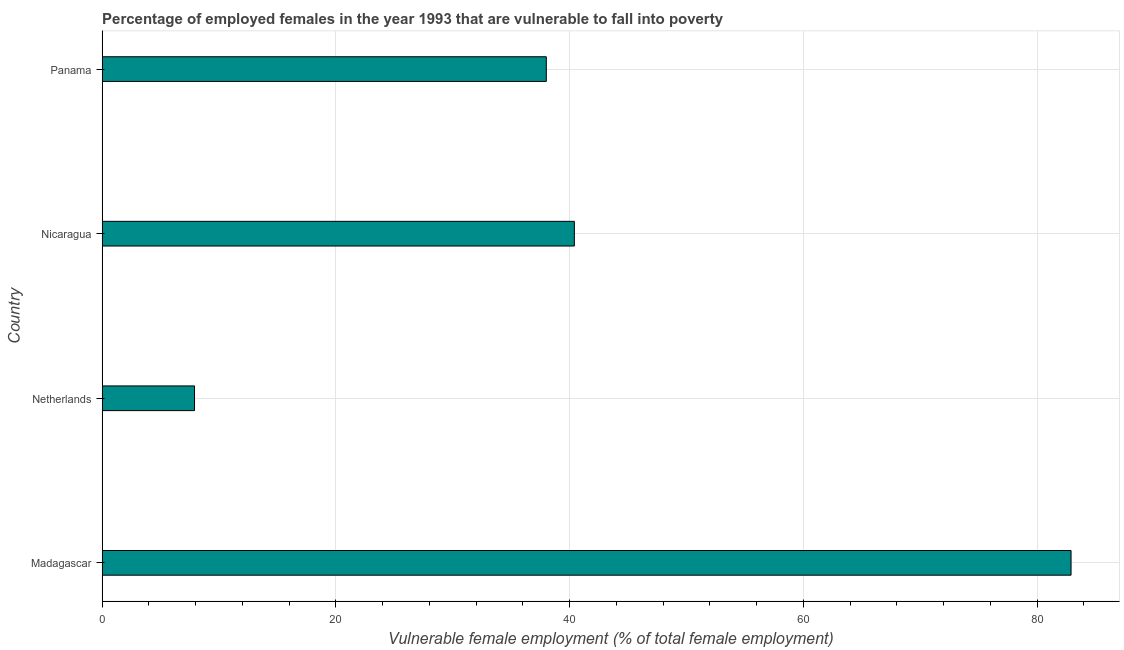Does the graph contain any zero values?
Make the answer very short. No. What is the title of the graph?
Give a very brief answer. Percentage of employed females in the year 1993 that are vulnerable to fall into poverty. What is the label or title of the X-axis?
Offer a terse response. Vulnerable female employment (% of total female employment). What is the label or title of the Y-axis?
Provide a short and direct response. Country. What is the percentage of employed females who are vulnerable to fall into poverty in Madagascar?
Offer a very short reply. 82.9. Across all countries, what is the maximum percentage of employed females who are vulnerable to fall into poverty?
Provide a short and direct response. 82.9. Across all countries, what is the minimum percentage of employed females who are vulnerable to fall into poverty?
Your answer should be compact. 7.9. In which country was the percentage of employed females who are vulnerable to fall into poverty maximum?
Make the answer very short. Madagascar. What is the sum of the percentage of employed females who are vulnerable to fall into poverty?
Your response must be concise. 169.2. What is the difference between the percentage of employed females who are vulnerable to fall into poverty in Netherlands and Panama?
Provide a short and direct response. -30.1. What is the average percentage of employed females who are vulnerable to fall into poverty per country?
Give a very brief answer. 42.3. What is the median percentage of employed females who are vulnerable to fall into poverty?
Make the answer very short. 39.2. What is the ratio of the percentage of employed females who are vulnerable to fall into poverty in Nicaragua to that in Panama?
Your answer should be compact. 1.06. Is the difference between the percentage of employed females who are vulnerable to fall into poverty in Madagascar and Netherlands greater than the difference between any two countries?
Make the answer very short. Yes. What is the difference between the highest and the second highest percentage of employed females who are vulnerable to fall into poverty?
Provide a succinct answer. 42.5. Is the sum of the percentage of employed females who are vulnerable to fall into poverty in Madagascar and Netherlands greater than the maximum percentage of employed females who are vulnerable to fall into poverty across all countries?
Provide a succinct answer. Yes. How many bars are there?
Your answer should be very brief. 4. Are all the bars in the graph horizontal?
Make the answer very short. Yes. What is the difference between two consecutive major ticks on the X-axis?
Make the answer very short. 20. What is the Vulnerable female employment (% of total female employment) in Madagascar?
Offer a terse response. 82.9. What is the Vulnerable female employment (% of total female employment) of Netherlands?
Give a very brief answer. 7.9. What is the Vulnerable female employment (% of total female employment) in Nicaragua?
Your answer should be compact. 40.4. What is the difference between the Vulnerable female employment (% of total female employment) in Madagascar and Nicaragua?
Your response must be concise. 42.5. What is the difference between the Vulnerable female employment (% of total female employment) in Madagascar and Panama?
Provide a succinct answer. 44.9. What is the difference between the Vulnerable female employment (% of total female employment) in Netherlands and Nicaragua?
Your response must be concise. -32.5. What is the difference between the Vulnerable female employment (% of total female employment) in Netherlands and Panama?
Your answer should be compact. -30.1. What is the difference between the Vulnerable female employment (% of total female employment) in Nicaragua and Panama?
Keep it short and to the point. 2.4. What is the ratio of the Vulnerable female employment (% of total female employment) in Madagascar to that in Netherlands?
Your response must be concise. 10.49. What is the ratio of the Vulnerable female employment (% of total female employment) in Madagascar to that in Nicaragua?
Your answer should be very brief. 2.05. What is the ratio of the Vulnerable female employment (% of total female employment) in Madagascar to that in Panama?
Offer a very short reply. 2.18. What is the ratio of the Vulnerable female employment (% of total female employment) in Netherlands to that in Nicaragua?
Provide a short and direct response. 0.2. What is the ratio of the Vulnerable female employment (% of total female employment) in Netherlands to that in Panama?
Your answer should be very brief. 0.21. What is the ratio of the Vulnerable female employment (% of total female employment) in Nicaragua to that in Panama?
Give a very brief answer. 1.06. 